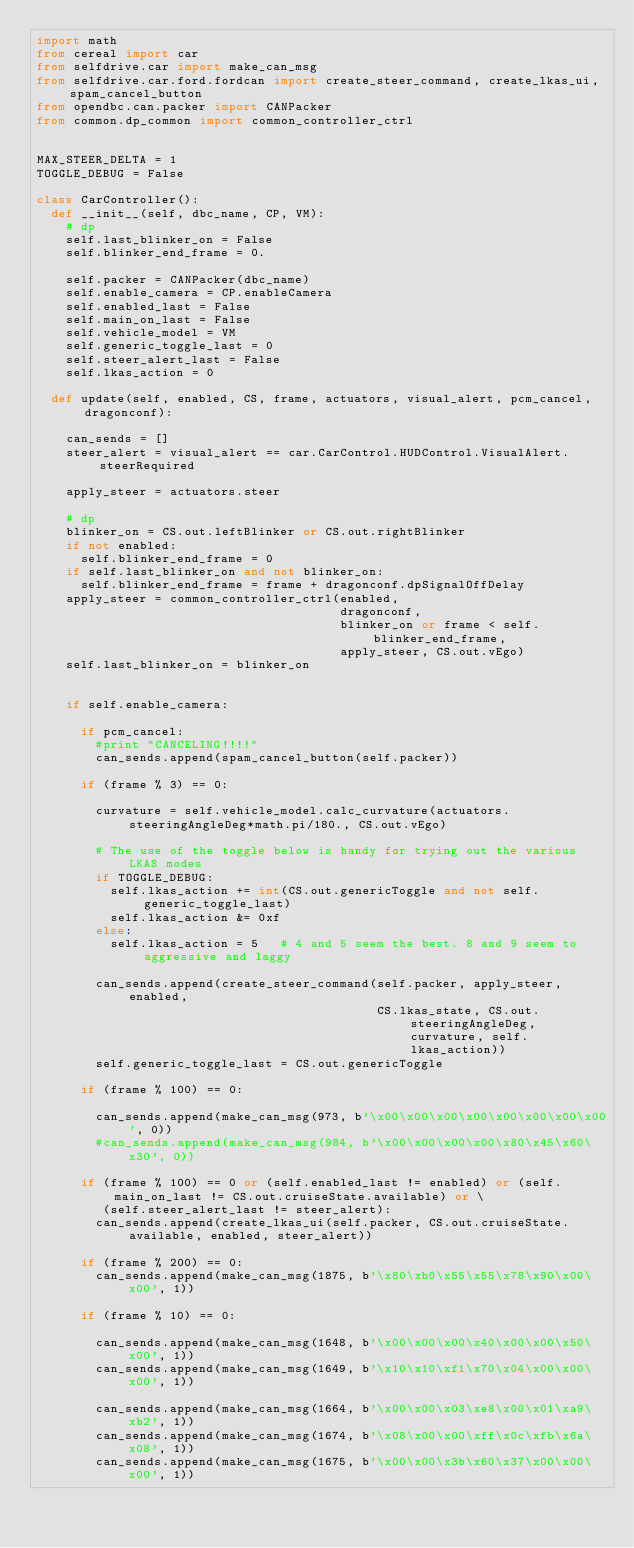Convert code to text. <code><loc_0><loc_0><loc_500><loc_500><_Python_>import math
from cereal import car
from selfdrive.car import make_can_msg
from selfdrive.car.ford.fordcan import create_steer_command, create_lkas_ui, spam_cancel_button
from opendbc.can.packer import CANPacker
from common.dp_common import common_controller_ctrl


MAX_STEER_DELTA = 1
TOGGLE_DEBUG = False

class CarController():
  def __init__(self, dbc_name, CP, VM):
    # dp
    self.last_blinker_on = False
    self.blinker_end_frame = 0.

    self.packer = CANPacker(dbc_name)
    self.enable_camera = CP.enableCamera
    self.enabled_last = False
    self.main_on_last = False
    self.vehicle_model = VM
    self.generic_toggle_last = 0
    self.steer_alert_last = False
    self.lkas_action = 0

  def update(self, enabled, CS, frame, actuators, visual_alert, pcm_cancel, dragonconf):

    can_sends = []
    steer_alert = visual_alert == car.CarControl.HUDControl.VisualAlert.steerRequired

    apply_steer = actuators.steer

    # dp
    blinker_on = CS.out.leftBlinker or CS.out.rightBlinker
    if not enabled:
      self.blinker_end_frame = 0
    if self.last_blinker_on and not blinker_on:
      self.blinker_end_frame = frame + dragonconf.dpSignalOffDelay
    apply_steer = common_controller_ctrl(enabled,
                                         dragonconf,
                                         blinker_on or frame < self.blinker_end_frame,
                                         apply_steer, CS.out.vEgo)
    self.last_blinker_on = blinker_on


    if self.enable_camera:

      if pcm_cancel:
        #print "CANCELING!!!!"
        can_sends.append(spam_cancel_button(self.packer))

      if (frame % 3) == 0:

        curvature = self.vehicle_model.calc_curvature(actuators.steeringAngleDeg*math.pi/180., CS.out.vEgo)

        # The use of the toggle below is handy for trying out the various LKAS modes
        if TOGGLE_DEBUG:
          self.lkas_action += int(CS.out.genericToggle and not self.generic_toggle_last)
          self.lkas_action &= 0xf
        else:
          self.lkas_action = 5   # 4 and 5 seem the best. 8 and 9 seem to aggressive and laggy

        can_sends.append(create_steer_command(self.packer, apply_steer, enabled,
                                              CS.lkas_state, CS.out.steeringAngleDeg, curvature, self.lkas_action))
        self.generic_toggle_last = CS.out.genericToggle

      if (frame % 100) == 0:

        can_sends.append(make_can_msg(973, b'\x00\x00\x00\x00\x00\x00\x00\x00', 0))
        #can_sends.append(make_can_msg(984, b'\x00\x00\x00\x00\x80\x45\x60\x30', 0))

      if (frame % 100) == 0 or (self.enabled_last != enabled) or (self.main_on_last != CS.out.cruiseState.available) or \
         (self.steer_alert_last != steer_alert):
        can_sends.append(create_lkas_ui(self.packer, CS.out.cruiseState.available, enabled, steer_alert))

      if (frame % 200) == 0:
        can_sends.append(make_can_msg(1875, b'\x80\xb0\x55\x55\x78\x90\x00\x00', 1))

      if (frame % 10) == 0:

        can_sends.append(make_can_msg(1648, b'\x00\x00\x00\x40\x00\x00\x50\x00', 1))
        can_sends.append(make_can_msg(1649, b'\x10\x10\xf1\x70\x04\x00\x00\x00', 1))

        can_sends.append(make_can_msg(1664, b'\x00\x00\x03\xe8\x00\x01\xa9\xb2', 1))
        can_sends.append(make_can_msg(1674, b'\x08\x00\x00\xff\x0c\xfb\x6a\x08', 1))
        can_sends.append(make_can_msg(1675, b'\x00\x00\x3b\x60\x37\x00\x00\x00', 1))</code> 